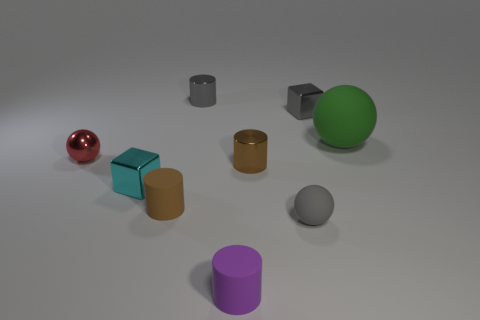Do the big green object and the small red thing have the same material? no 